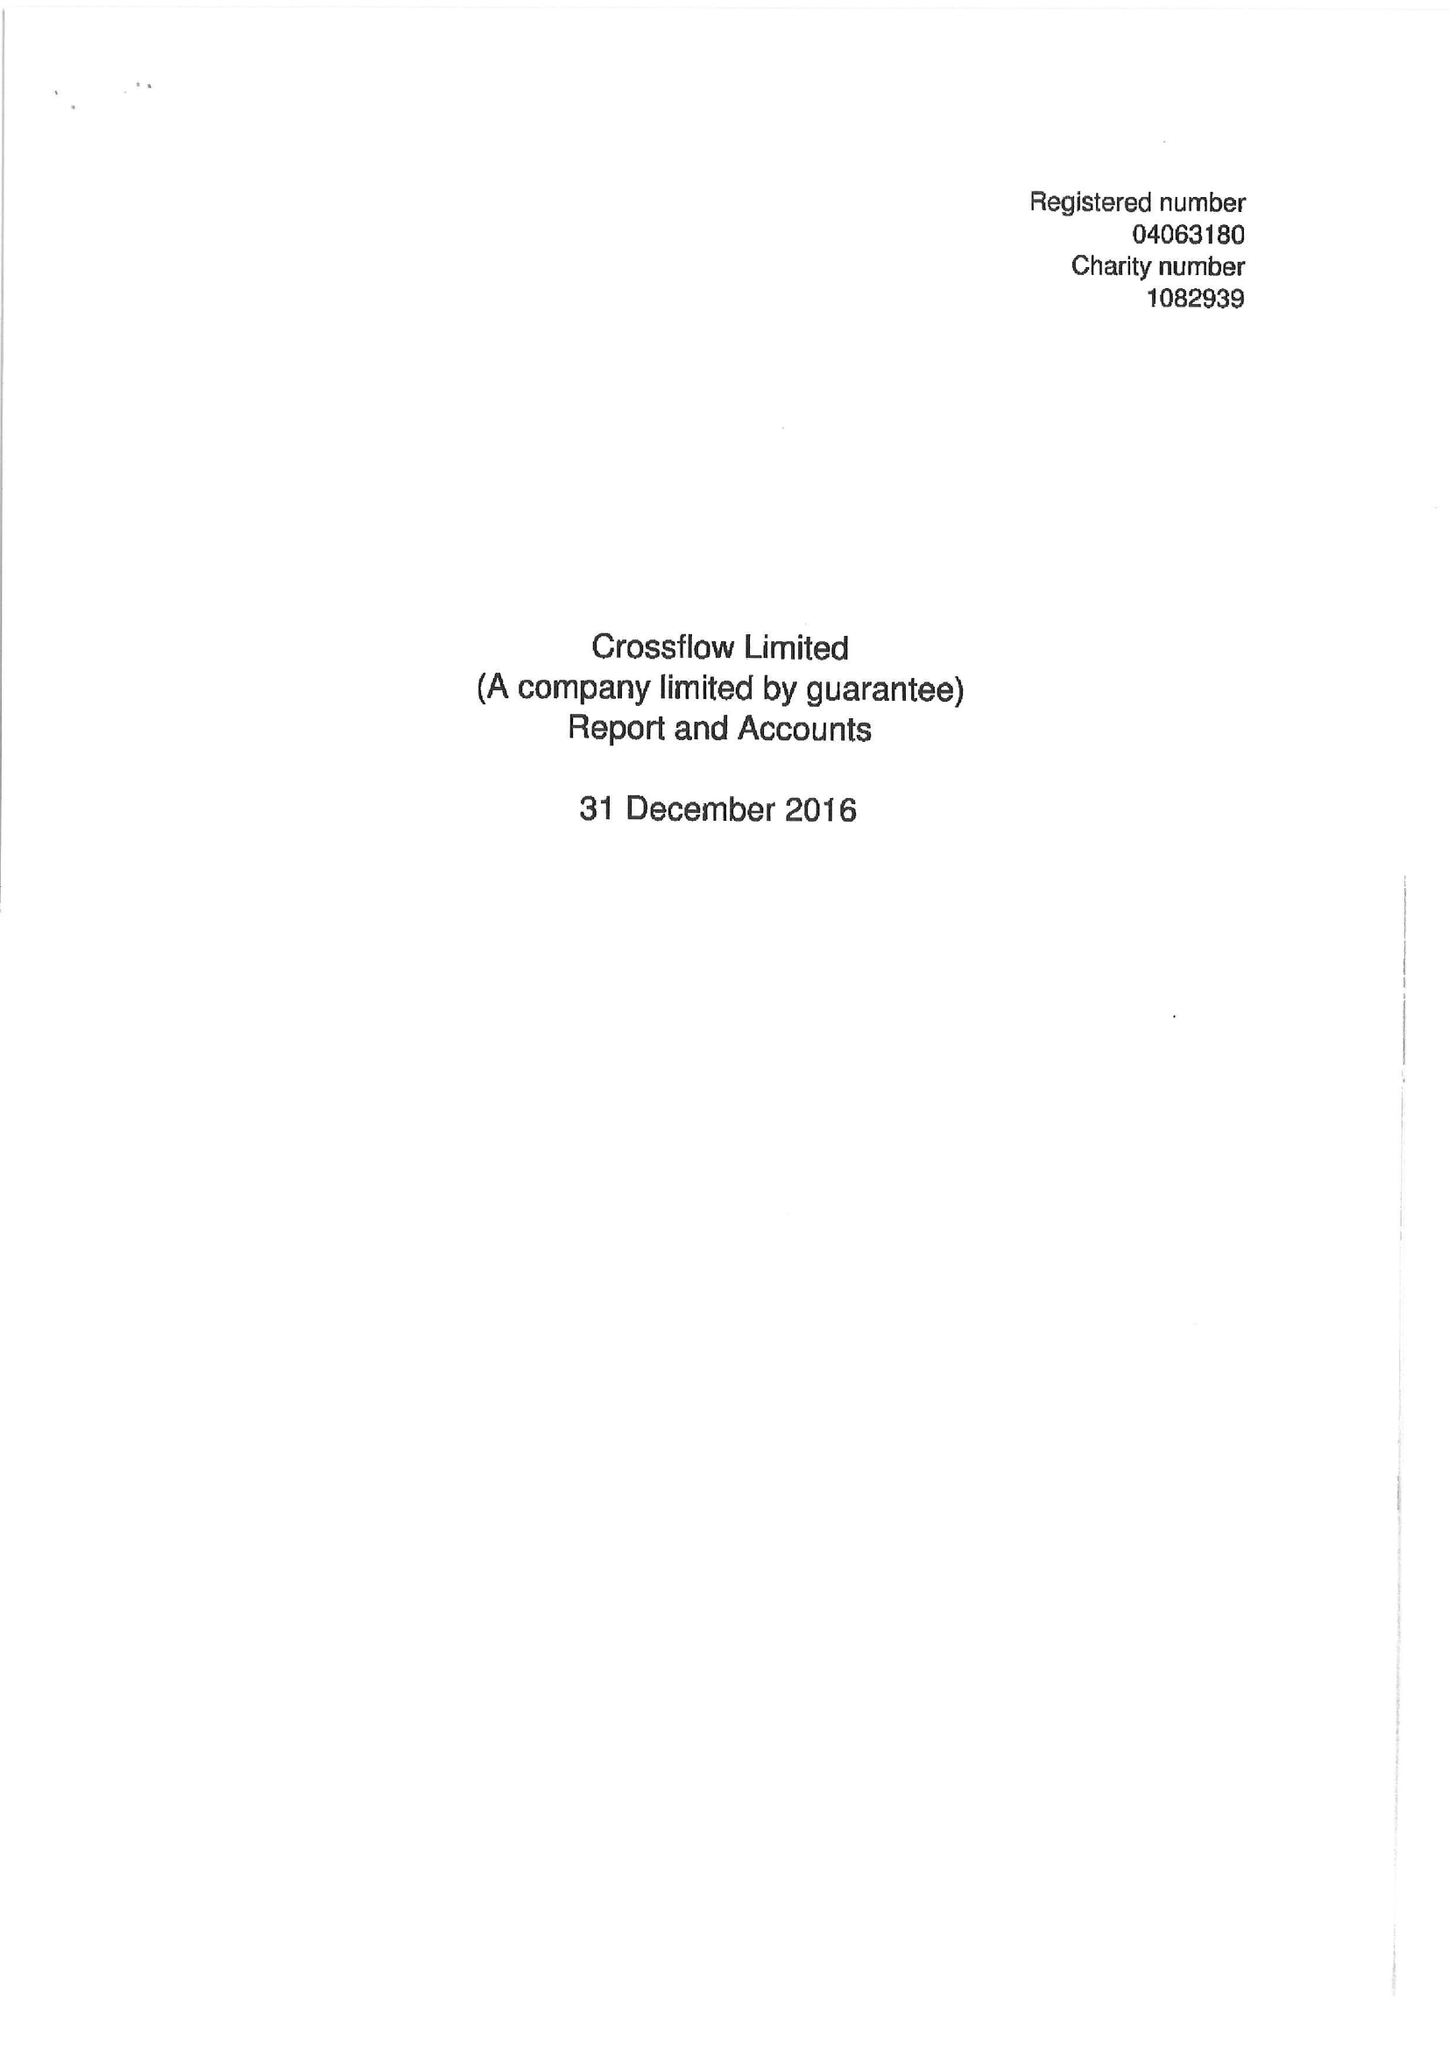What is the value for the address__postcode?
Answer the question using a single word or phrase. SW1H 0HW 